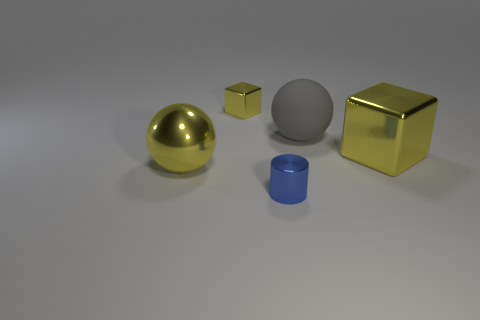How many objects are there, and can you tell me about their shapes? There are four objects in the image, each with a distinct geometric shape. From left to right, we have a sphere that is perfectly round, a small cube that boasts equal-length edges, a cylinder which is circular in its base and elongated in height, and finally, a larger cube with equal-length edges like the smaller one but with a bigger volume. 